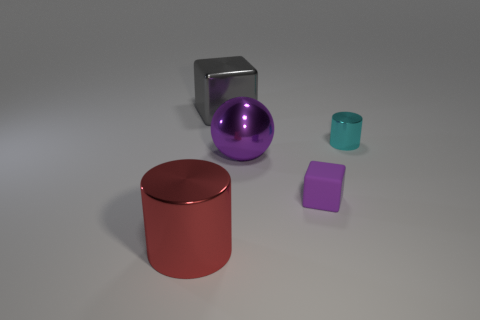Is the gray cube made of the same material as the purple cube?
Your response must be concise. No. What is the size of the red metal thing that is the same shape as the small cyan thing?
Provide a succinct answer. Large. What color is the object that is to the left of the tiny purple object and in front of the purple metal object?
Your answer should be compact. Red. Is the size of the cylinder that is to the right of the red cylinder the same as the large sphere?
Offer a terse response. No. Is there anything else that has the same shape as the purple metal thing?
Provide a short and direct response. No. Is the sphere made of the same material as the cylinder left of the metal cube?
Offer a very short reply. Yes. What number of blue objects are either tiny matte cylinders or small blocks?
Provide a succinct answer. 0. Are any small metallic things visible?
Offer a terse response. Yes. There is a thing left of the block that is left of the tiny rubber thing; is there a thing behind it?
Provide a succinct answer. Yes. There is a big gray thing; is it the same shape as the small thing that is on the left side of the tiny cyan object?
Give a very brief answer. Yes. 